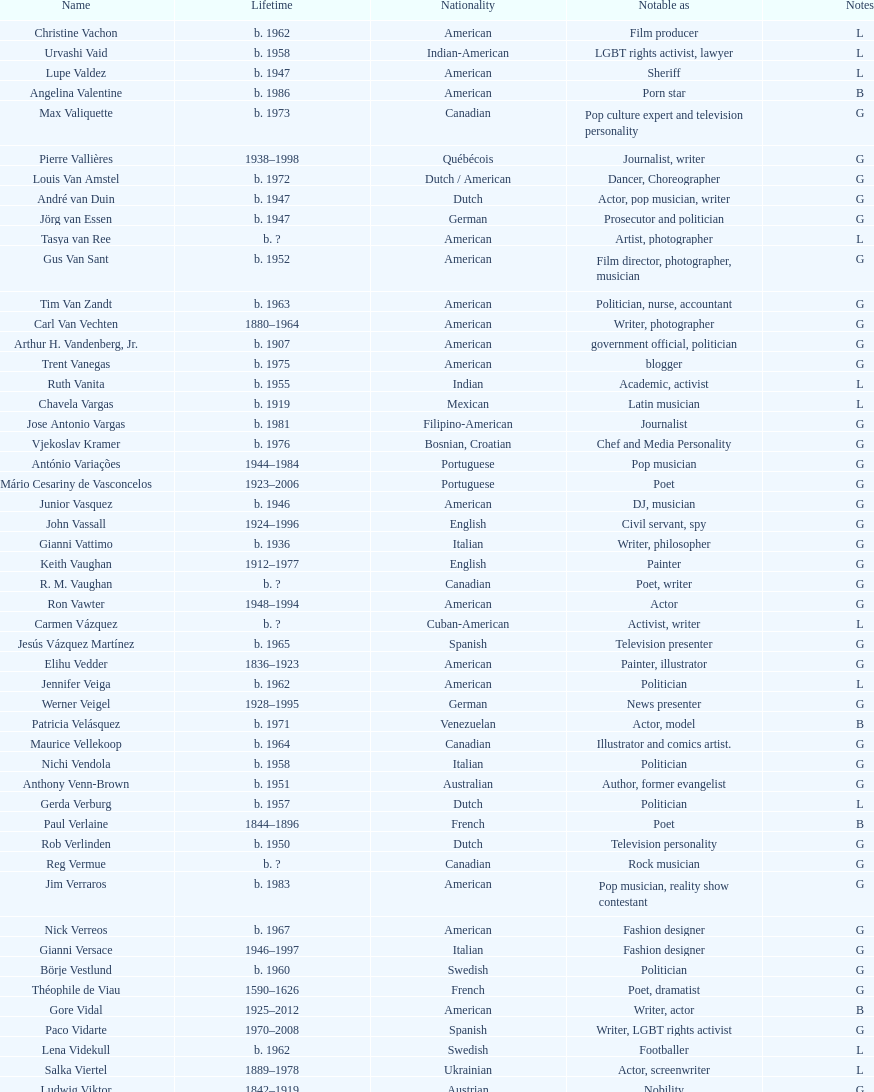Which is the previous name from lupe valdez Urvashi Vaid. 